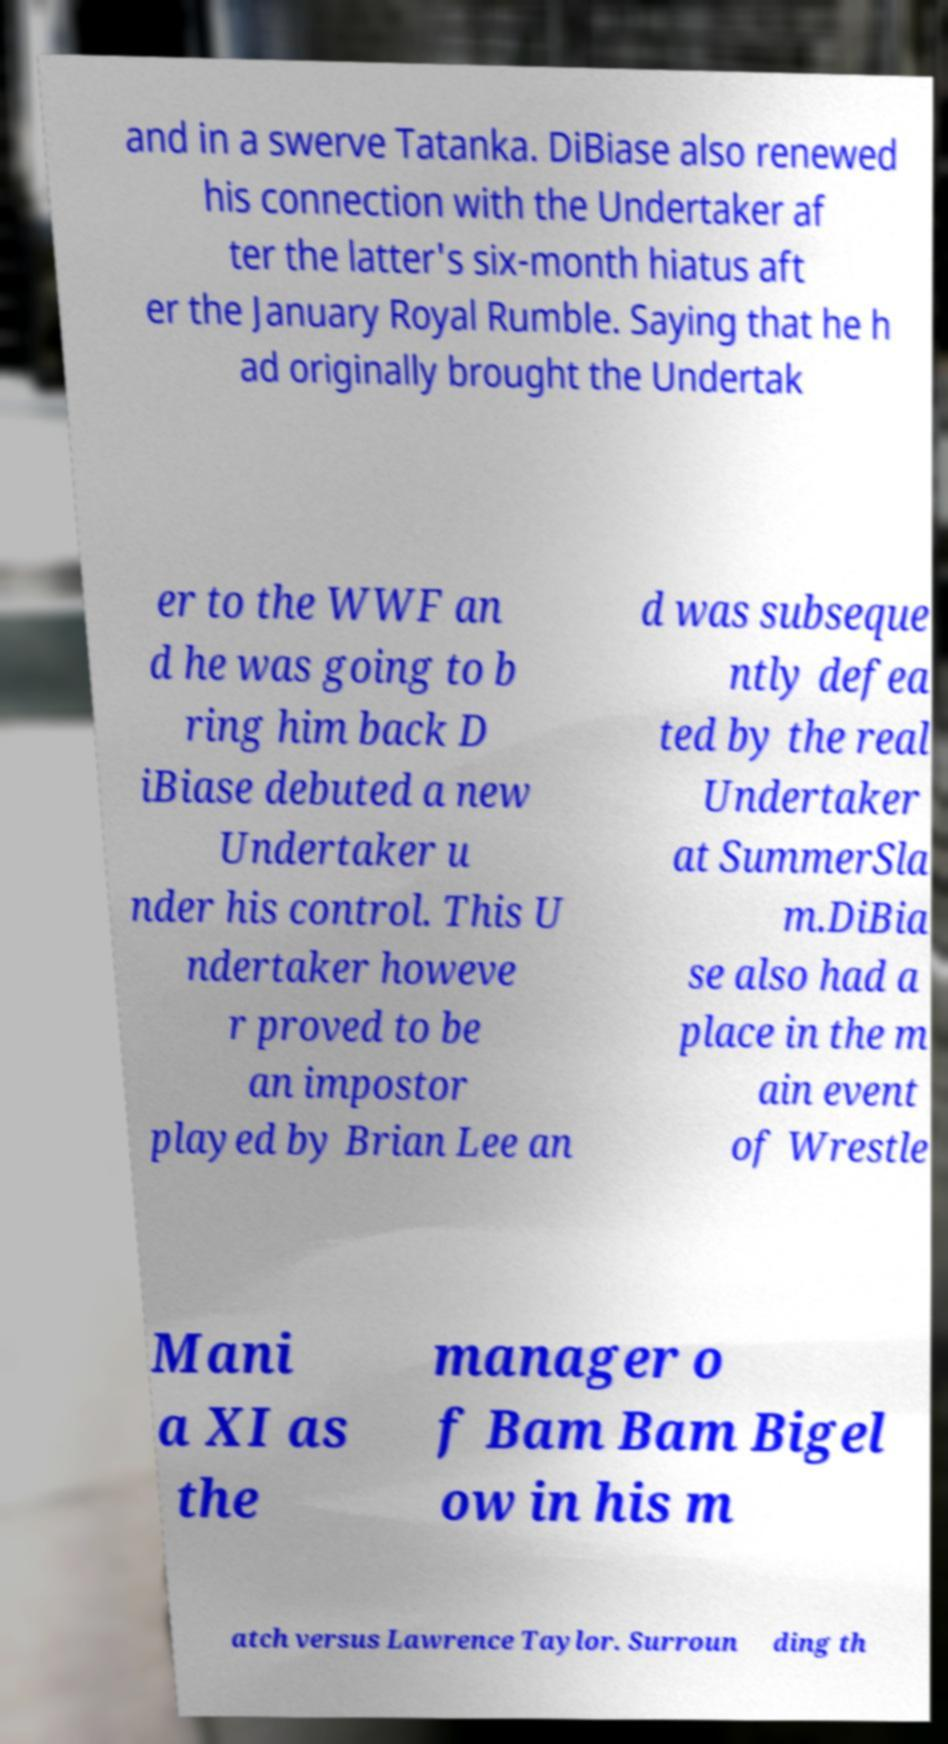Please read and relay the text visible in this image. What does it say? and in a swerve Tatanka. DiBiase also renewed his connection with the Undertaker af ter the latter's six-month hiatus aft er the January Royal Rumble. Saying that he h ad originally brought the Undertak er to the WWF an d he was going to b ring him back D iBiase debuted a new Undertaker u nder his control. This U ndertaker howeve r proved to be an impostor played by Brian Lee an d was subseque ntly defea ted by the real Undertaker at SummerSla m.DiBia se also had a place in the m ain event of Wrestle Mani a XI as the manager o f Bam Bam Bigel ow in his m atch versus Lawrence Taylor. Surroun ding th 